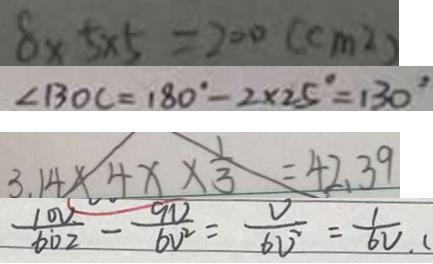Convert formula to latex. <formula><loc_0><loc_0><loc_500><loc_500>8 \times 5 \times 5 = 2 0 0 ( c m ^ { 2 } ) 
 \angle B O C = 1 8 0 ^ { \circ } - 2 \times 2 5 ^ { \circ } = 1 3 0 ^ { \circ } 
 3 . 1 4 \times 4 x \times \frac { 1 } { 3 } = 4 2 . 3 9 
 \frac { 1 0 V } { 6 0 2 } - \frac { 9 V } { 6 V ^ { 2 } } = \frac { V } { 6 V ^ { 2 } } = \frac { 1 } { 6 V } . (</formula> 